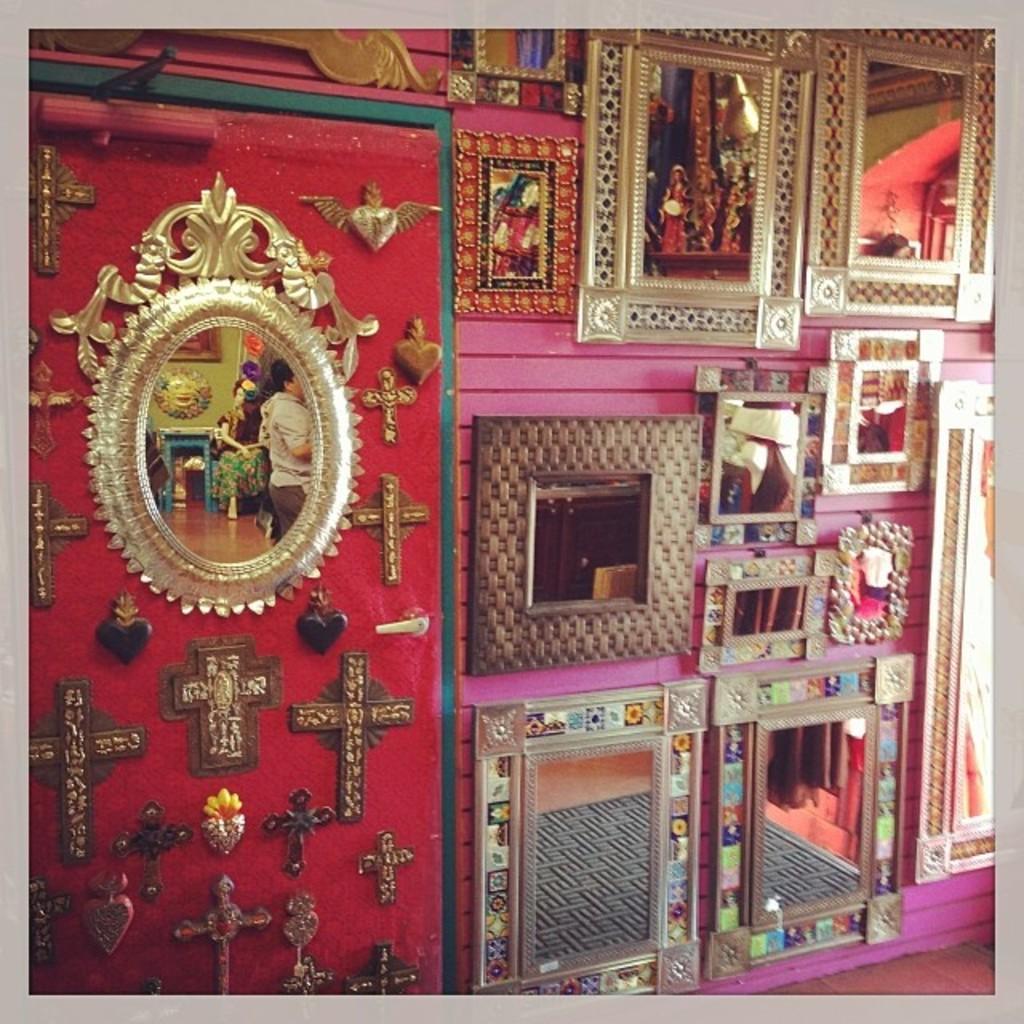Please provide a concise description of this image. In this picture I can see there are few mirrors placed on the wall and there are cross symbols at left and there are few more mirrors at right side, there is a reflection of a carpet on the floor in the mirror. 